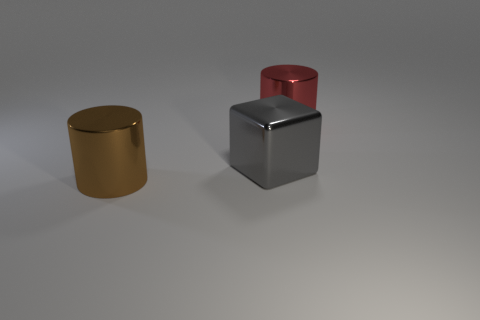There is a shiny object on the left side of the gray metal thing on the right side of the large brown shiny cylinder; what is its shape?
Provide a succinct answer. Cylinder. How many blue things are big metallic objects or big cylinders?
Offer a terse response. 0. There is a big gray object; are there any shiny objects behind it?
Give a very brief answer. Yes. What is the size of the red metallic cylinder?
Provide a short and direct response. Large. The other shiny object that is the same shape as the brown thing is what size?
Give a very brief answer. Large. There is a big shiny cylinder that is behind the brown thing; how many big gray things are to the left of it?
Your answer should be very brief. 1. Do the thing that is left of the gray cube and the cylinder that is to the right of the large gray cube have the same material?
Give a very brief answer. Yes. How many brown rubber objects have the same shape as the brown shiny thing?
Ensure brevity in your answer.  0. What number of other cubes have the same color as the metallic cube?
Offer a very short reply. 0. Is the shape of the big gray thing behind the brown object the same as the metallic object that is to the left of the gray shiny thing?
Make the answer very short. No. 